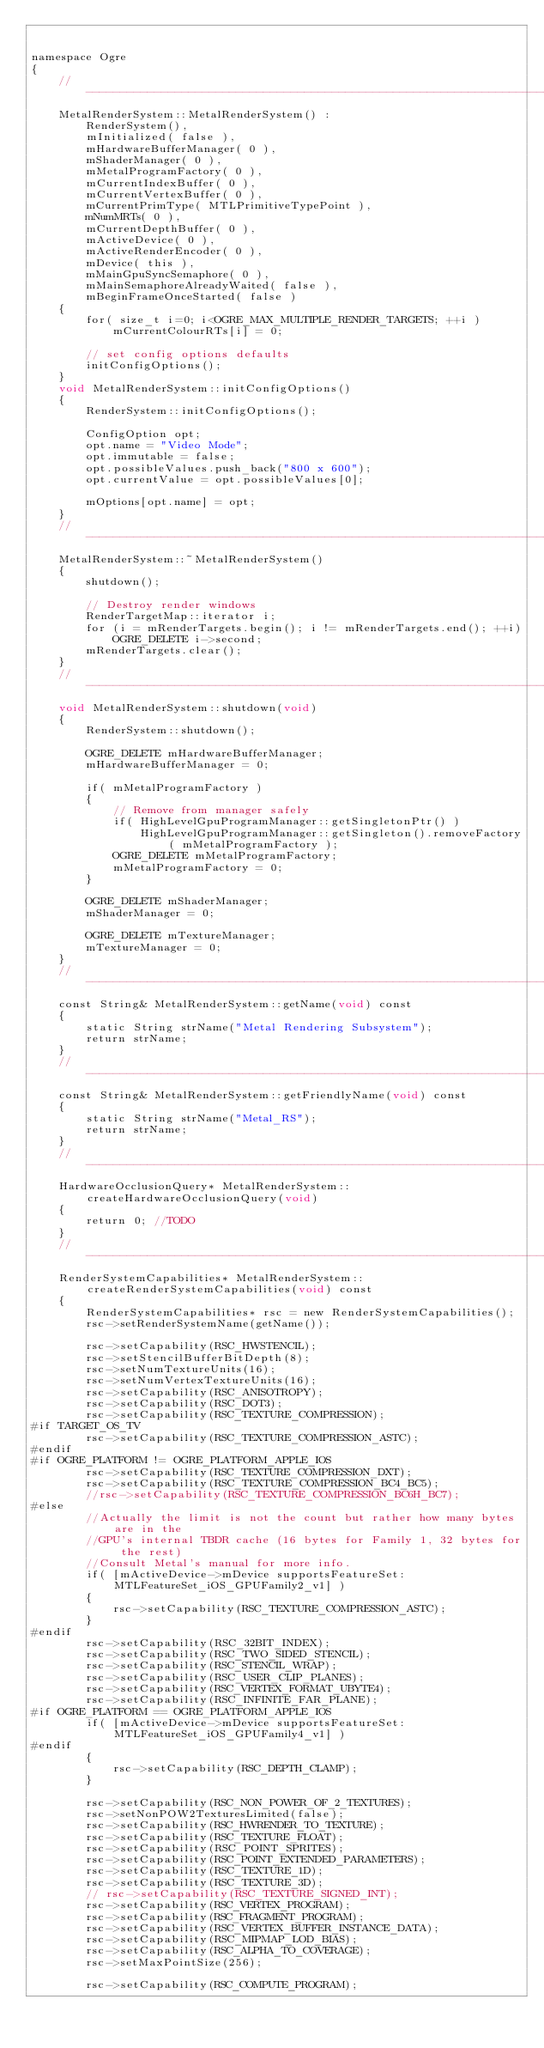Convert code to text. <code><loc_0><loc_0><loc_500><loc_500><_ObjectiveC_>

namespace Ogre
{
    //-------------------------------------------------------------------------
    MetalRenderSystem::MetalRenderSystem() :
        RenderSystem(),
        mInitialized( false ),
        mHardwareBufferManager( 0 ),
        mShaderManager( 0 ),
        mMetalProgramFactory( 0 ),
        mCurrentIndexBuffer( 0 ),
        mCurrentVertexBuffer( 0 ),
        mCurrentPrimType( MTLPrimitiveTypePoint ),
        mNumMRTs( 0 ),
        mCurrentDepthBuffer( 0 ),
        mActiveDevice( 0 ),
        mActiveRenderEncoder( 0 ),
        mDevice( this ),
        mMainGpuSyncSemaphore( 0 ),
        mMainSemaphoreAlreadyWaited( false ),
        mBeginFrameOnceStarted( false )
    {
        for( size_t i=0; i<OGRE_MAX_MULTIPLE_RENDER_TARGETS; ++i )
            mCurrentColourRTs[i] = 0;

        // set config options defaults
        initConfigOptions();
    }
    void MetalRenderSystem::initConfigOptions()
    {
        RenderSystem::initConfigOptions();

        ConfigOption opt;
        opt.name = "Video Mode";
        opt.immutable = false;
        opt.possibleValues.push_back("800 x 600");
        opt.currentValue = opt.possibleValues[0];

        mOptions[opt.name] = opt;
    }
    //-------------------------------------------------------------------------
    MetalRenderSystem::~MetalRenderSystem()
    {
        shutdown();

        // Destroy render windows
        RenderTargetMap::iterator i;
        for (i = mRenderTargets.begin(); i != mRenderTargets.end(); ++i)
            OGRE_DELETE i->second;
        mRenderTargets.clear();
    }
    //-------------------------------------------------------------------------
    void MetalRenderSystem::shutdown(void)
    {
        RenderSystem::shutdown();

        OGRE_DELETE mHardwareBufferManager;
        mHardwareBufferManager = 0;

        if( mMetalProgramFactory )
        {
            // Remove from manager safely
            if( HighLevelGpuProgramManager::getSingletonPtr() )
                HighLevelGpuProgramManager::getSingleton().removeFactory( mMetalProgramFactory );
            OGRE_DELETE mMetalProgramFactory;
            mMetalProgramFactory = 0;
        }

        OGRE_DELETE mShaderManager;
        mShaderManager = 0;

        OGRE_DELETE mTextureManager;
        mTextureManager = 0;
    }
    //-------------------------------------------------------------------------
    const String& MetalRenderSystem::getName(void) const
    {
        static String strName("Metal Rendering Subsystem");
        return strName;
    }
    //-------------------------------------------------------------------------
    const String& MetalRenderSystem::getFriendlyName(void) const
    {
        static String strName("Metal_RS");
        return strName;
    }
    //-------------------------------------------------------------------------
    HardwareOcclusionQuery* MetalRenderSystem::createHardwareOcclusionQuery(void)
    {
        return 0; //TODO
    }
    //-------------------------------------------------------------------------
    RenderSystemCapabilities* MetalRenderSystem::createRenderSystemCapabilities(void) const
    {
        RenderSystemCapabilities* rsc = new RenderSystemCapabilities();
        rsc->setRenderSystemName(getName());

        rsc->setCapability(RSC_HWSTENCIL);
        rsc->setStencilBufferBitDepth(8);
        rsc->setNumTextureUnits(16);
        rsc->setNumVertexTextureUnits(16);
        rsc->setCapability(RSC_ANISOTROPY);
        rsc->setCapability(RSC_DOT3);
        rsc->setCapability(RSC_TEXTURE_COMPRESSION);
#if TARGET_OS_TV
        rsc->setCapability(RSC_TEXTURE_COMPRESSION_ASTC);
#endif
#if OGRE_PLATFORM != OGRE_PLATFORM_APPLE_IOS
        rsc->setCapability(RSC_TEXTURE_COMPRESSION_DXT);
        rsc->setCapability(RSC_TEXTURE_COMPRESSION_BC4_BC5);
        //rsc->setCapability(RSC_TEXTURE_COMPRESSION_BC6H_BC7);
#else
        //Actually the limit is not the count but rather how many bytes are in the
        //GPU's internal TBDR cache (16 bytes for Family 1, 32 bytes for the rest)
        //Consult Metal's manual for more info.
        if( [mActiveDevice->mDevice supportsFeatureSet:MTLFeatureSet_iOS_GPUFamily2_v1] )
        {
            rsc->setCapability(RSC_TEXTURE_COMPRESSION_ASTC);
        }
#endif
        rsc->setCapability(RSC_32BIT_INDEX);
        rsc->setCapability(RSC_TWO_SIDED_STENCIL);
        rsc->setCapability(RSC_STENCIL_WRAP);
        rsc->setCapability(RSC_USER_CLIP_PLANES);
        rsc->setCapability(RSC_VERTEX_FORMAT_UBYTE4);
        rsc->setCapability(RSC_INFINITE_FAR_PLANE);
#if OGRE_PLATFORM == OGRE_PLATFORM_APPLE_IOS
        if( [mActiveDevice->mDevice supportsFeatureSet:MTLFeatureSet_iOS_GPUFamily4_v1] )
#endif
        {
            rsc->setCapability(RSC_DEPTH_CLAMP);
        }

        rsc->setCapability(RSC_NON_POWER_OF_2_TEXTURES);
        rsc->setNonPOW2TexturesLimited(false);
        rsc->setCapability(RSC_HWRENDER_TO_TEXTURE);
        rsc->setCapability(RSC_TEXTURE_FLOAT);
        rsc->setCapability(RSC_POINT_SPRITES);
        rsc->setCapability(RSC_POINT_EXTENDED_PARAMETERS);
        rsc->setCapability(RSC_TEXTURE_1D);
        rsc->setCapability(RSC_TEXTURE_3D);
        // rsc->setCapability(RSC_TEXTURE_SIGNED_INT);
        rsc->setCapability(RSC_VERTEX_PROGRAM);
        rsc->setCapability(RSC_FRAGMENT_PROGRAM);
        rsc->setCapability(RSC_VERTEX_BUFFER_INSTANCE_DATA);
        rsc->setCapability(RSC_MIPMAP_LOD_BIAS);
        rsc->setCapability(RSC_ALPHA_TO_COVERAGE);
        rsc->setMaxPointSize(256);

        rsc->setCapability(RSC_COMPUTE_PROGRAM);</code> 